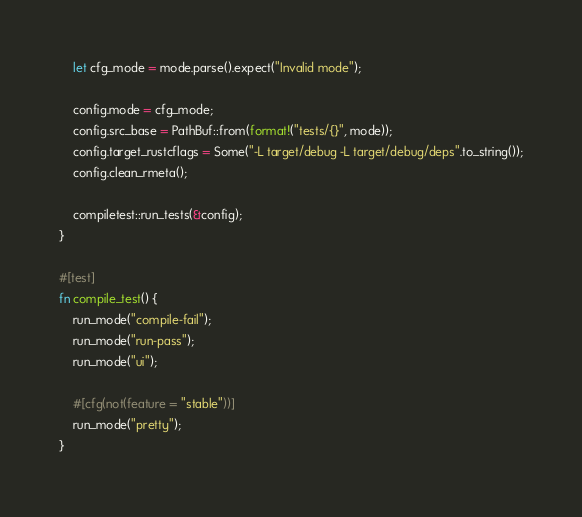<code> <loc_0><loc_0><loc_500><loc_500><_Rust_>    let cfg_mode = mode.parse().expect("Invalid mode");

    config.mode = cfg_mode;
    config.src_base = PathBuf::from(format!("tests/{}", mode));
    config.target_rustcflags = Some("-L target/debug -L target/debug/deps".to_string());
    config.clean_rmeta();

    compiletest::run_tests(&config);
}

#[test]
fn compile_test() {
    run_mode("compile-fail");
    run_mode("run-pass");
    run_mode("ui");

    #[cfg(not(feature = "stable"))]
    run_mode("pretty");
}
</code> 